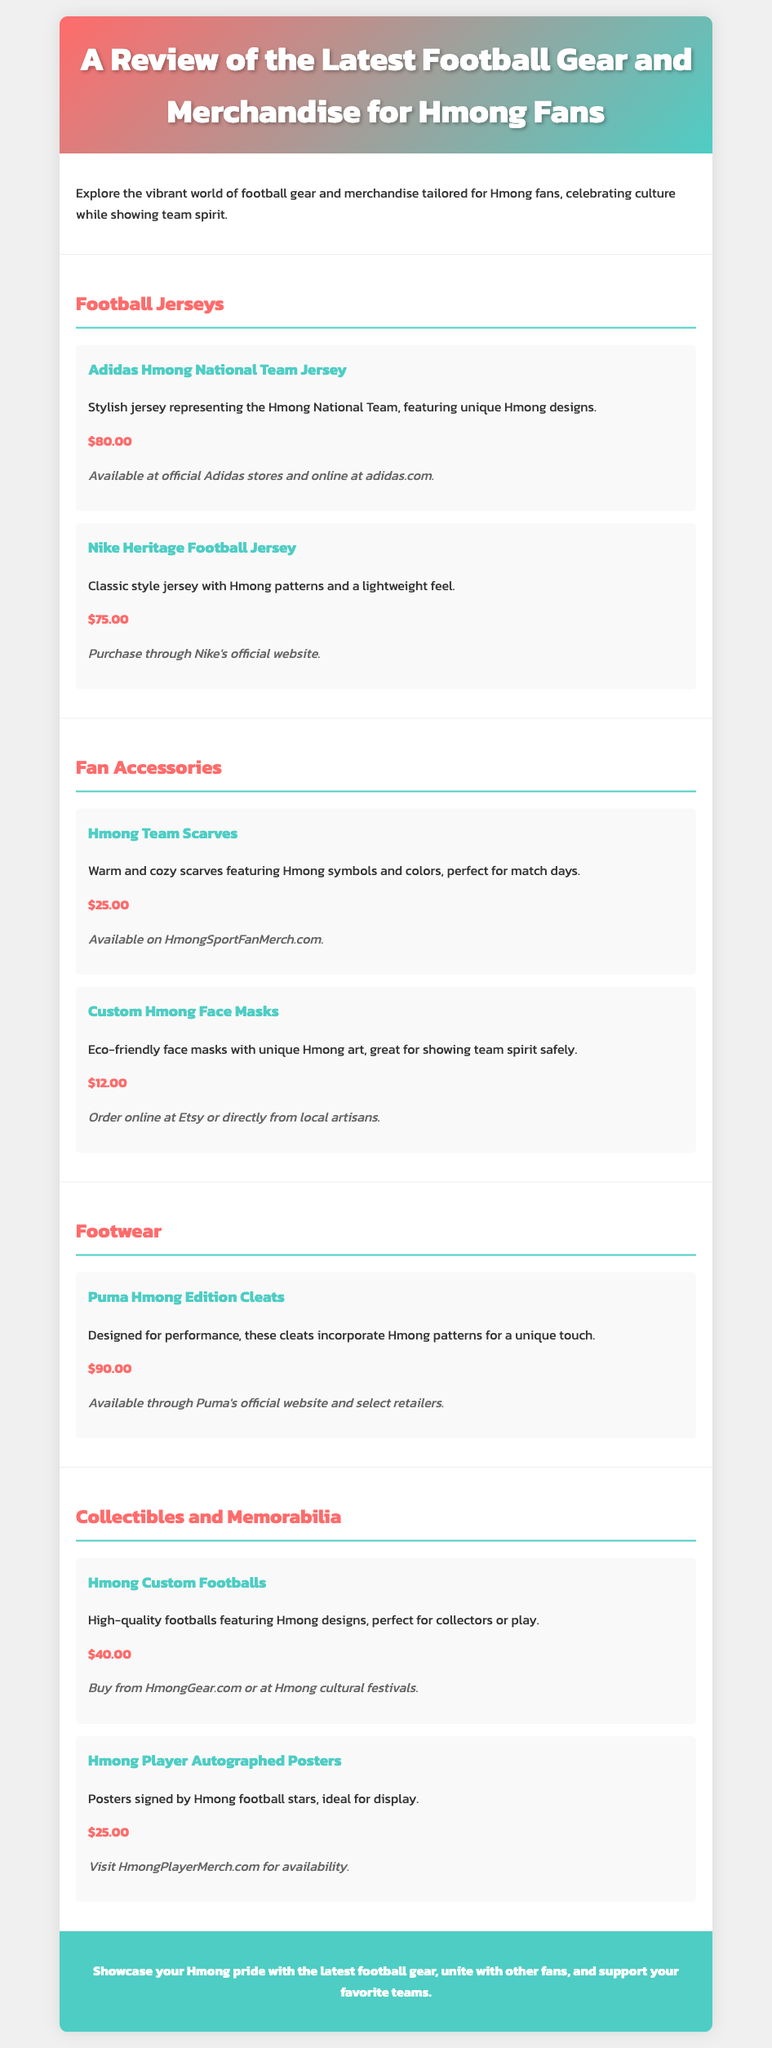What is the price of the Adidas Hmong National Team Jersey? The price of the Adidas Hmong National Team Jersey is listed in the document.
Answer: $80.00 Where can the Nike Heritage Football Jersey be purchased? The document specifies where to buy the Nike Heritage Football Jersey.
Answer: Nike's official website What are the two types of fan accessories mentioned? The document details the fan accessories section, including specific items.
Answer: Hmong Team Scarves, Custom Hmong Face Masks How much does the Puma Hmong Edition Cleats cost? The price for the Puma Hmong Edition Cleats is given among the footwear options.
Answer: $90.00 What unique design does the Hmong Custom Football feature? The Hmong Custom Football is described to include special designs relevant to the Hmong culture.
Answer: Hmong designs Which type of merchandise includes signed memorabilia? The document discusses some collectibles that feature signatures from players.
Answer: Hmong Player Autographed Posters What is the total number of football jersey options listed? By counting the jersey options mentioned in the document's jersey section, we can find the total.
Answer: 2 What is the purchase option for Hmong Team Scarves? The document provides a specific website where Hmong Team Scarves can be bought.
Answer: HmongSportFanMerch.com Which color gradients are used in the header? The document describes the header's background, providing details about the color scheme.
Answer: #ff6b6b, #4ecdc4 